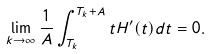Convert formula to latex. <formula><loc_0><loc_0><loc_500><loc_500>\lim _ { k \to \infty } \frac { 1 } { A } \int _ { T _ { k } } ^ { T _ { k } + A } t H ^ { \prime } ( t ) d t = 0 .</formula> 